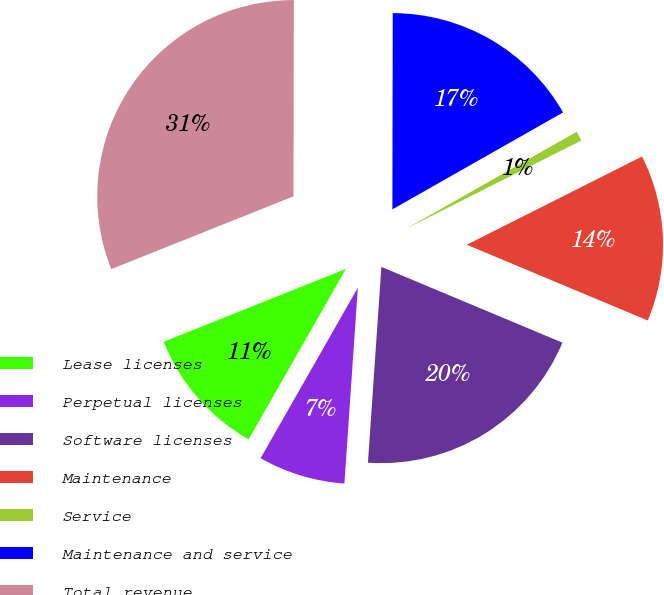Convert chart to OTSL. <chart><loc_0><loc_0><loc_500><loc_500><pie_chart><fcel>Lease licenses<fcel>Perpetual licenses<fcel>Software licenses<fcel>Maintenance<fcel>Service<fcel>Maintenance and service<fcel>Total revenue<nl><fcel>10.7%<fcel>7.16%<fcel>19.78%<fcel>13.73%<fcel>0.8%<fcel>16.75%<fcel>31.07%<nl></chart> 